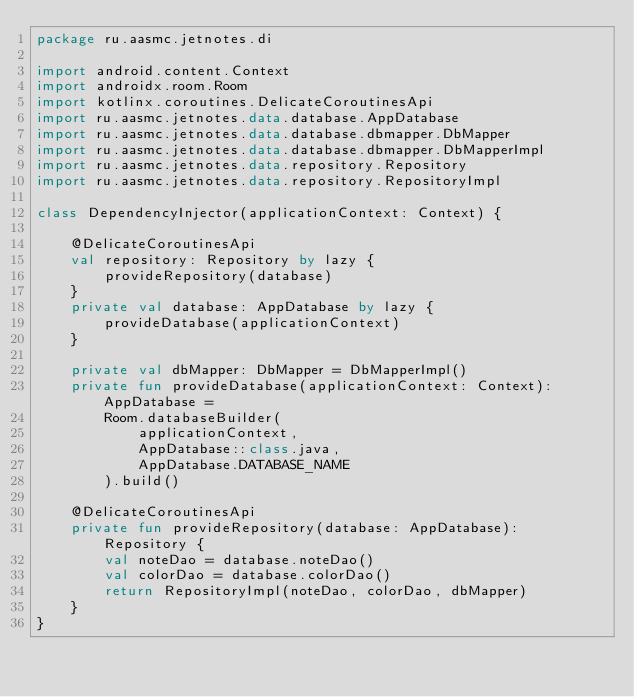<code> <loc_0><loc_0><loc_500><loc_500><_Kotlin_>package ru.aasmc.jetnotes.di

import android.content.Context
import androidx.room.Room
import kotlinx.coroutines.DelicateCoroutinesApi
import ru.aasmc.jetnotes.data.database.AppDatabase
import ru.aasmc.jetnotes.data.database.dbmapper.DbMapper
import ru.aasmc.jetnotes.data.database.dbmapper.DbMapperImpl
import ru.aasmc.jetnotes.data.repository.Repository
import ru.aasmc.jetnotes.data.repository.RepositoryImpl

class DependencyInjector(applicationContext: Context) {

    @DelicateCoroutinesApi
    val repository: Repository by lazy {
        provideRepository(database)
    }
    private val database: AppDatabase by lazy {
        provideDatabase(applicationContext)
    }

    private val dbMapper: DbMapper = DbMapperImpl()
    private fun provideDatabase(applicationContext: Context): AppDatabase =
        Room.databaseBuilder(
            applicationContext,
            AppDatabase::class.java,
            AppDatabase.DATABASE_NAME
        ).build()

    @DelicateCoroutinesApi
    private fun provideRepository(database: AppDatabase): Repository {
        val noteDao = database.noteDao()
        val colorDao = database.colorDao()
        return RepositoryImpl(noteDao, colorDao, dbMapper)
    }
}









</code> 